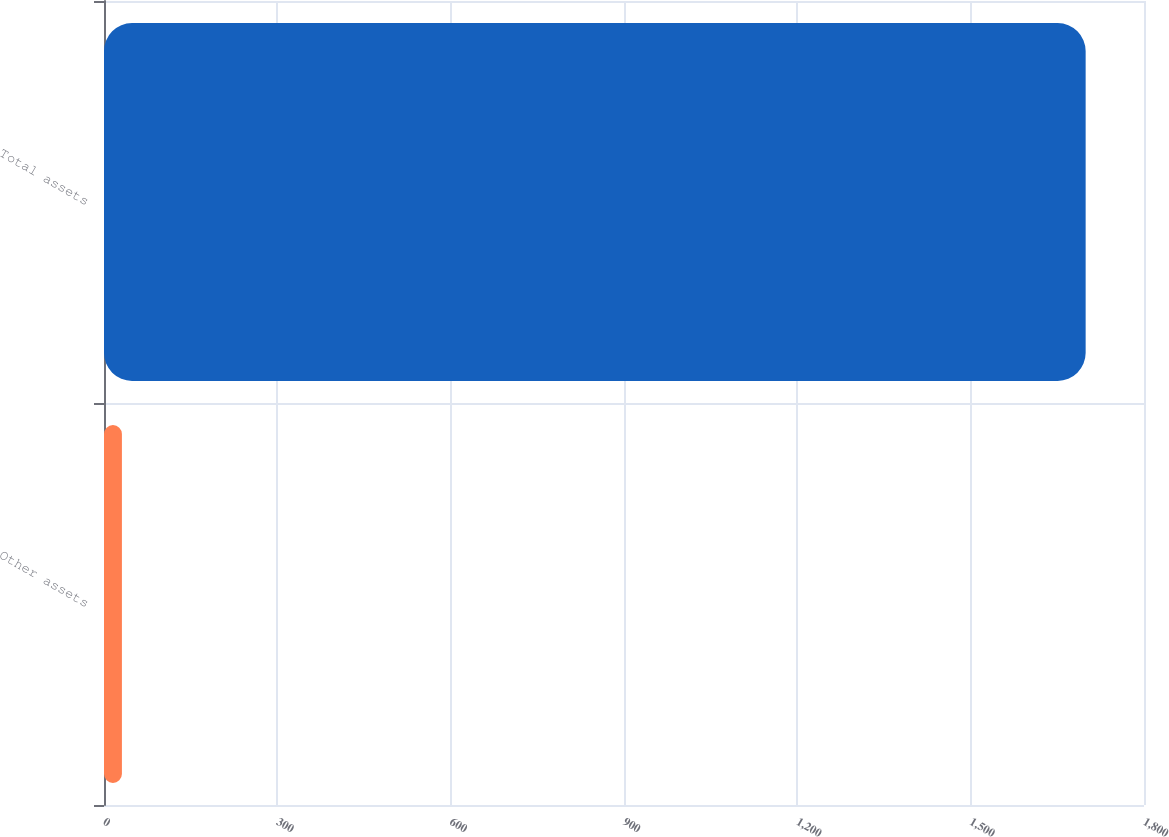Convert chart. <chart><loc_0><loc_0><loc_500><loc_500><bar_chart><fcel>Other assets<fcel>Total assets<nl><fcel>31<fcel>1699<nl></chart> 